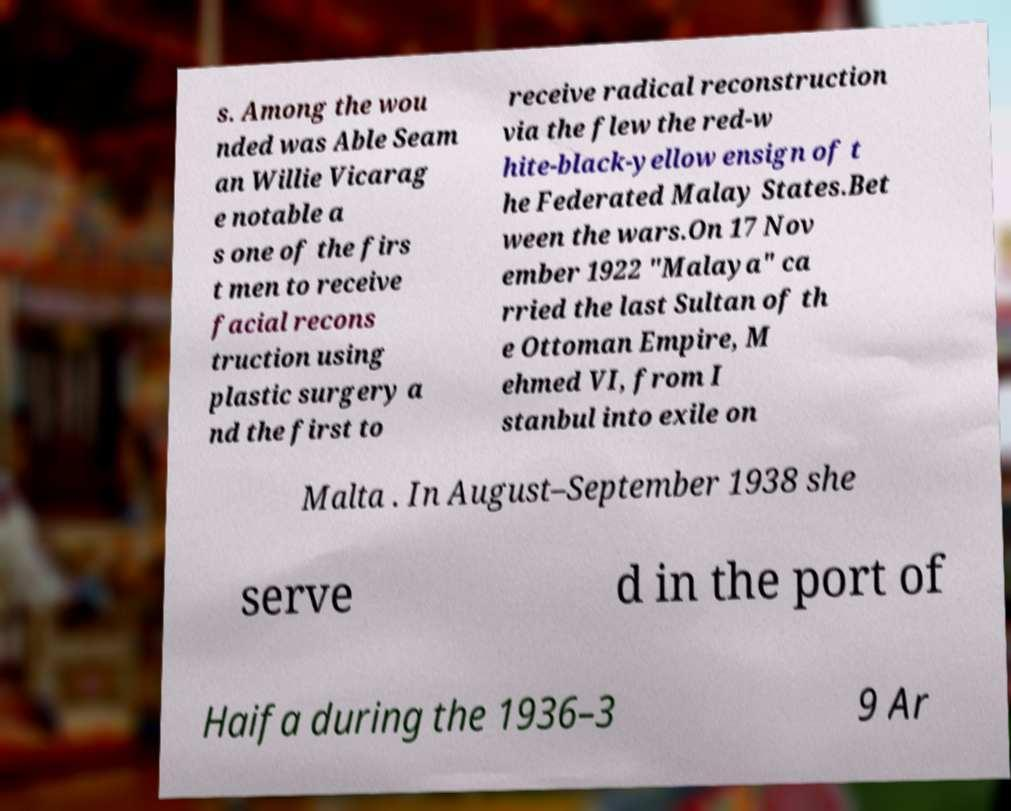Can you read and provide the text displayed in the image?This photo seems to have some interesting text. Can you extract and type it out for me? s. Among the wou nded was Able Seam an Willie Vicarag e notable a s one of the firs t men to receive facial recons truction using plastic surgery a nd the first to receive radical reconstruction via the flew the red-w hite-black-yellow ensign of t he Federated Malay States.Bet ween the wars.On 17 Nov ember 1922 "Malaya" ca rried the last Sultan of th e Ottoman Empire, M ehmed VI, from I stanbul into exile on Malta . In August–September 1938 she serve d in the port of Haifa during the 1936–3 9 Ar 